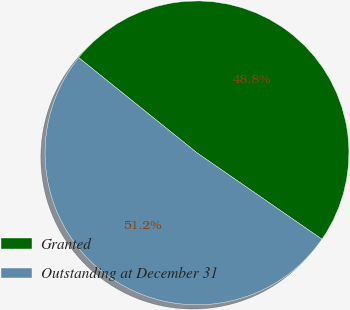Convert chart. <chart><loc_0><loc_0><loc_500><loc_500><pie_chart><fcel>Granted<fcel>Outstanding at December 31<nl><fcel>48.84%<fcel>51.16%<nl></chart> 